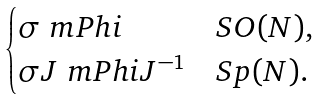<formula> <loc_0><loc_0><loc_500><loc_500>\begin{cases} \sigma \ m P h i & S O ( N ) , \\ \sigma J \ m P h i J ^ { - 1 } & S p ( N ) . \end{cases}</formula> 